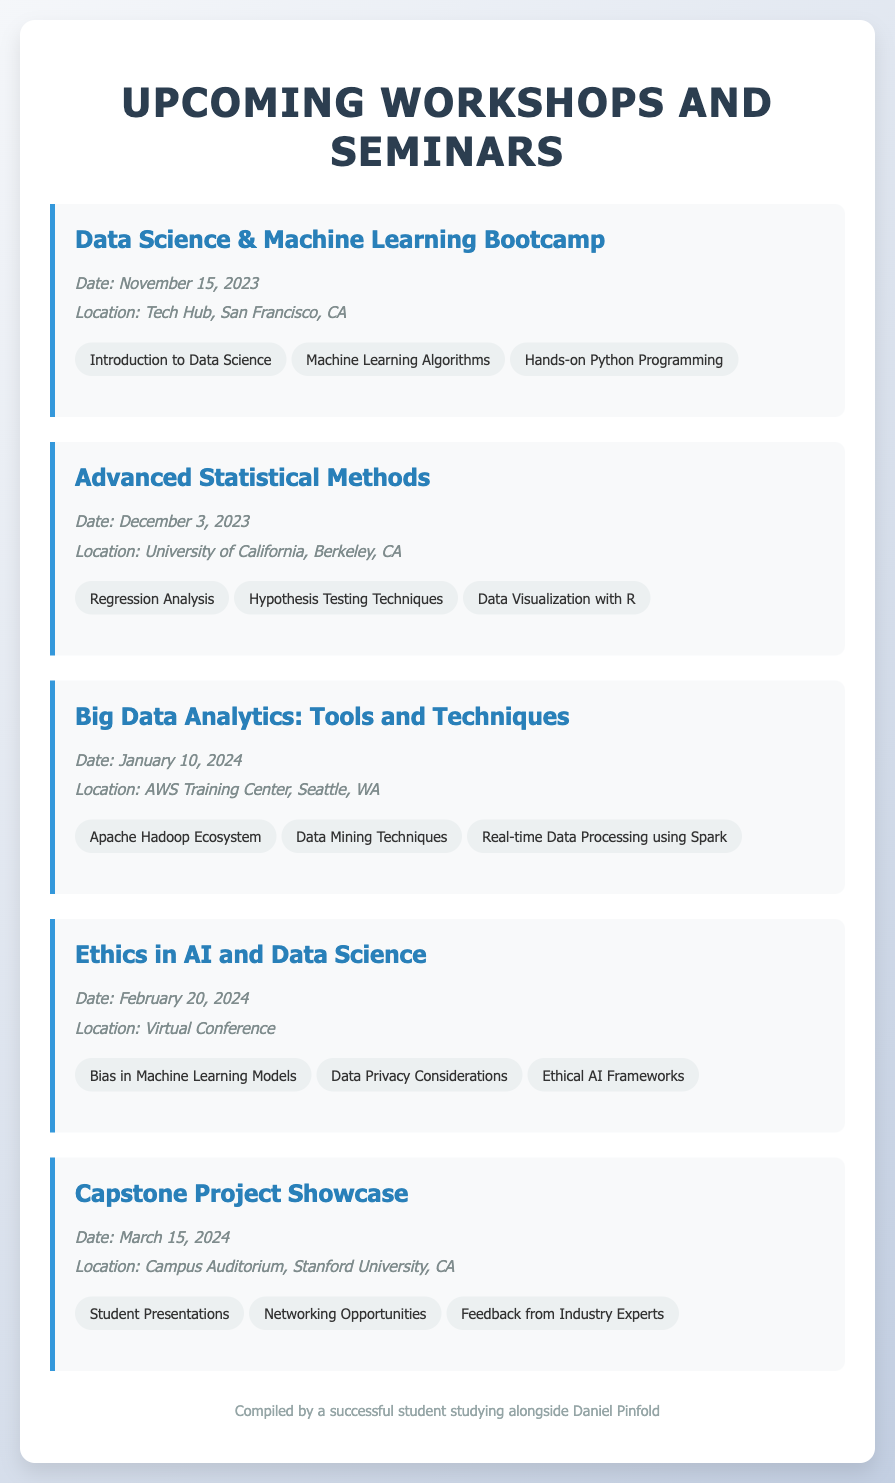What is the date of the first workshop? The first workshop listed is "Data Science & Machine Learning Bootcamp," scheduled for November 15, 2023.
Answer: November 15, 2023 Where is the "Advanced Statistical Methods" workshop taking place? The "Advanced Statistical Methods" workshop is located at the University of California, Berkeley, CA.
Answer: University of California, Berkeley, CA What topics will be covered in the "Ethics in AI and Data Science" workshop? The topics listed for this workshop include Bias in Machine Learning Models, Data Privacy Considerations, and Ethical AI Frameworks.
Answer: Bias in Machine Learning Models, Data Privacy Considerations, Ethical AI Frameworks When is the Capstone Project Showcase scheduled? The Capstone Project Showcase is scheduled for March 15, 2024, as per the document.
Answer: March 15, 2024 What is the location of the "Big Data Analytics: Tools and Techniques" workshop? The location specified for the "Big Data Analytics: Tools and Techniques" workshop is the AWS Training Center, Seattle, WA.
Answer: AWS Training Center, Seattle, WA What is the theme of the workshop held on February 20, 2024? The workshop on February 20, 2024, is themed "Ethics in AI and Data Science."
Answer: Ethics in AI and Data Science How many workshops are listed in the document? The document lists a total of five workshops.
Answer: Five Which workshop features student presentations? The workshop that features student presentations is the "Capstone Project Showcase."
Answer: Capstone Project Showcase 